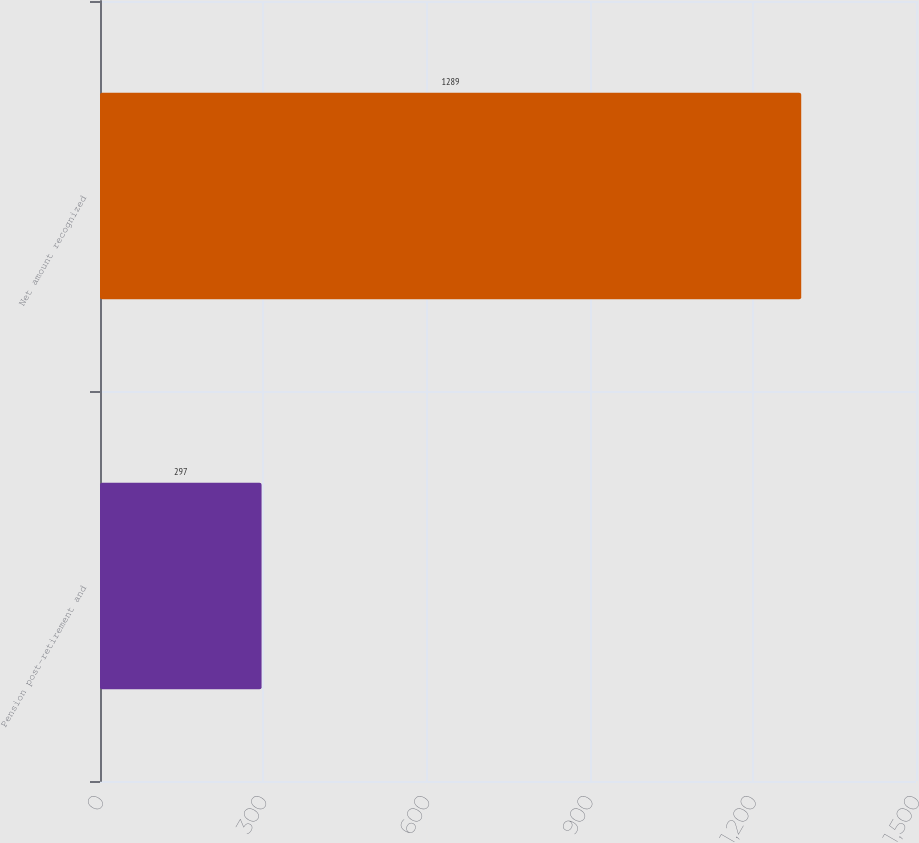Convert chart. <chart><loc_0><loc_0><loc_500><loc_500><bar_chart><fcel>Pension post-retirement and<fcel>Net amount recognized<nl><fcel>297<fcel>1289<nl></chart> 